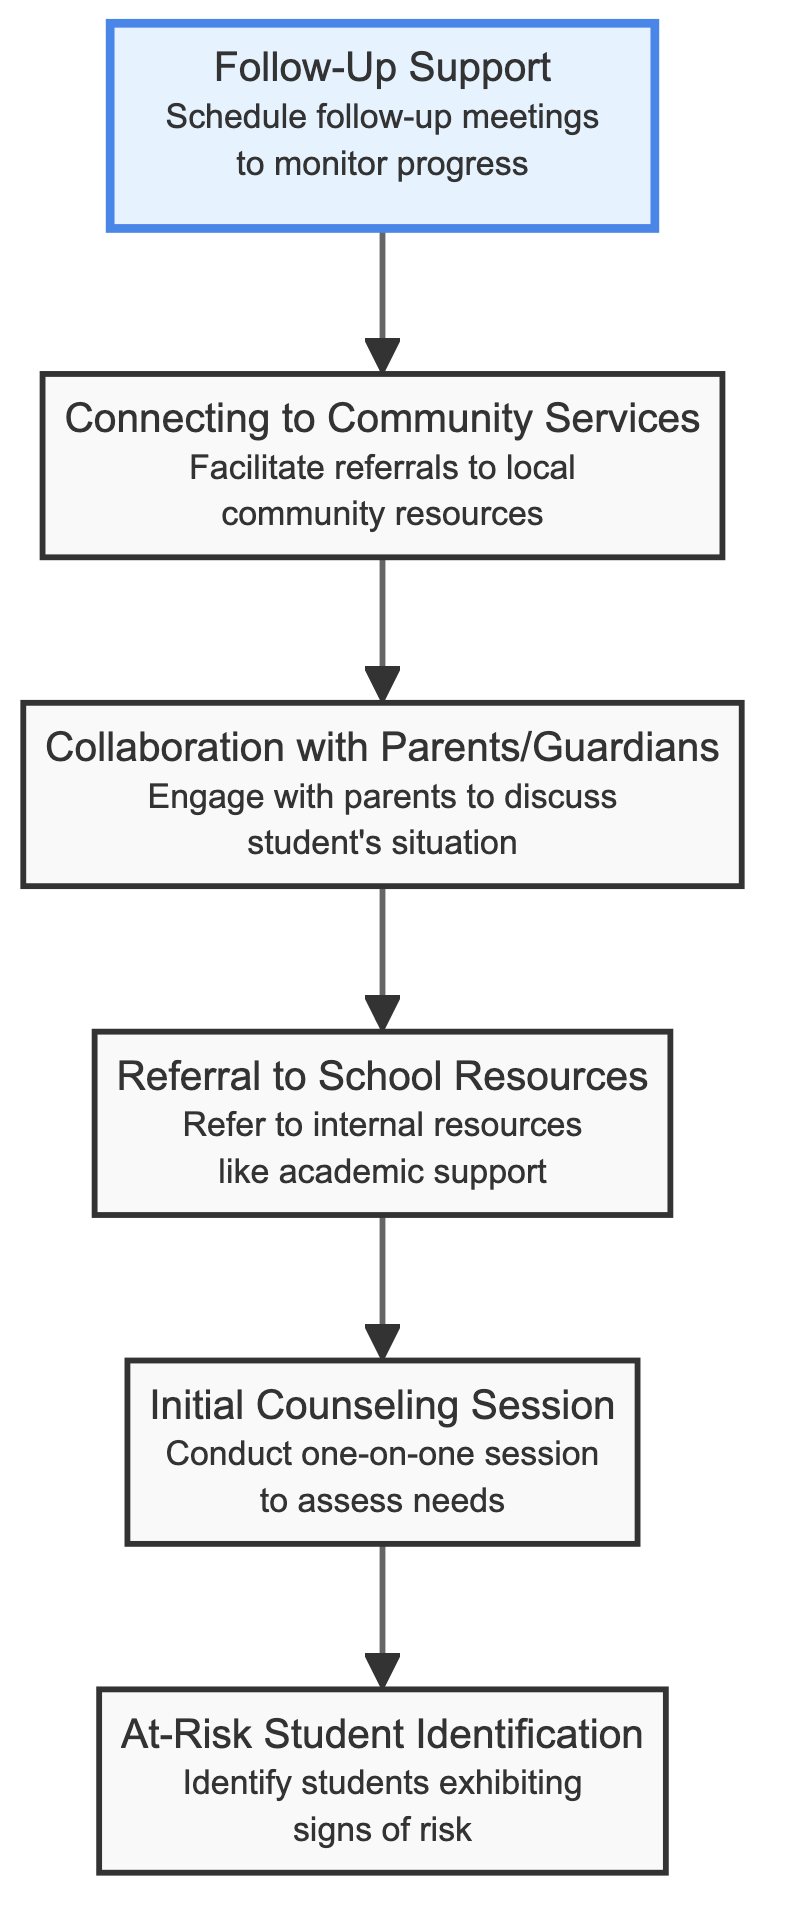What is the first step in the process? The diagram shows that the first step is "At-Risk Student Identification," which is the starting point for the referral process.
Answer: At-Risk Student Identification How many nodes are present in the diagram? The diagram lists a total of six elements, which are all the nodes representing different steps in the referral process.
Answer: 6 What is the last step in the flow chart? The last node in the flow chart is "Follow-Up Support," indicating it is the final step of the process.
Answer: Follow-Up Support Which step follows "Connecting to Community Services"? The diagram indicates that "Collaboration with Parents/Guardians" comes directly after "Connecting to Community Services," following the flow of actions in the process.
Answer: Collaboration with Parents/Guardians What step is immediately before the "Initial Counseling Session"? Looking at the flowchart, the step that directly precedes "Initial Counseling Session" is "Referral to School Resources," showing the flow from one action to another.
Answer: Referral to School Resources What color represents "At-Risk Student Identification"? In the diagram, "At-Risk Student Identification" is styled with a light red background, indicated by the fill color specified for that node.
Answer: Light red Which steps involve collaboration with others? The steps "Collaboration with Parents/Guardians" and "Follow-Up Support" both involve engaging with others, such as parents and monitoring progress, reflecting relational aspects of the process.
Answer: Collaboration with Parents/Guardians, Follow-Up Support Which step is considered a support service? The "Connecting to Community Services" step is aimed at facilitating referrals and providing additional support for at-risk students, making it a support service.
Answer: Connecting to Community Services How do internal resources relate to the overall process? Internal resources such as academic support or mental health services are referred to after the "Initial Counseling Session," showing their significance in addressing needs identified in the referral process.
Answer: They follow "Initial Counseling Session" 